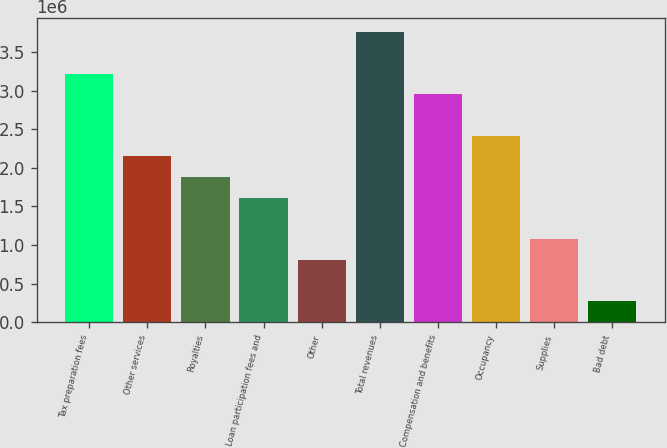Convert chart. <chart><loc_0><loc_0><loc_500><loc_500><bar_chart><fcel>Tax preparation fees<fcel>Other services<fcel>Royalties<fcel>Loan participation fees and<fcel>Other<fcel>Total revenues<fcel>Compensation and benefits<fcel>Occupancy<fcel>Supplies<fcel>Bad debt<nl><fcel>3.22302e+06<fcel>2.14869e+06<fcel>1.88011e+06<fcel>1.61153e+06<fcel>805776<fcel>3.76019e+06<fcel>2.95444e+06<fcel>2.41727e+06<fcel>1.07436e+06<fcel>268609<nl></chart> 